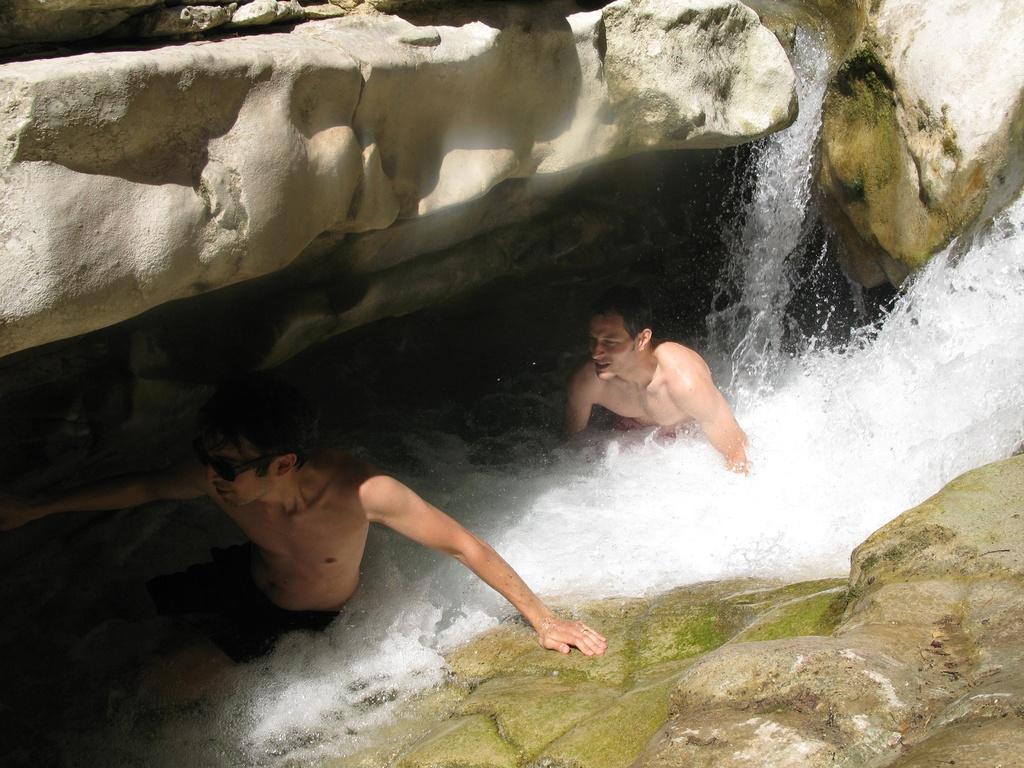How would you summarize this image in a sentence or two? In this picture we can see two people, one person is wearing a goggle, here we can see water and rocks. 